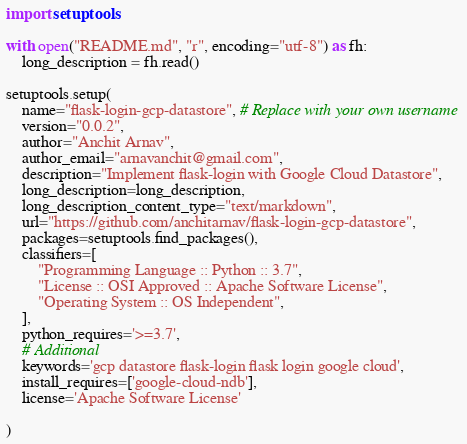<code> <loc_0><loc_0><loc_500><loc_500><_Python_>import setuptools

with open("README.md", "r", encoding="utf-8") as fh:
    long_description = fh.read()

setuptools.setup(
    name="flask-login-gcp-datastore", # Replace with your own username
    version="0.0.2",
    author="Anchit Arnav",
    author_email="arnavanchit@gmail.com",
    description="Implement flask-login with Google Cloud Datastore",
    long_description=long_description,
    long_description_content_type="text/markdown",
    url="https://github.com/anchitarnav/flask-login-gcp-datastore",
    packages=setuptools.find_packages(),
    classifiers=[
        "Programming Language :: Python :: 3.7",
        "License :: OSI Approved :: Apache Software License",
        "Operating System :: OS Independent",
    ],
    python_requires='>=3.7',
    # Additional
    keywords='gcp datastore flask-login flask login google cloud',
    install_requires=['google-cloud-ndb'],
    license='Apache Software License'

)</code> 